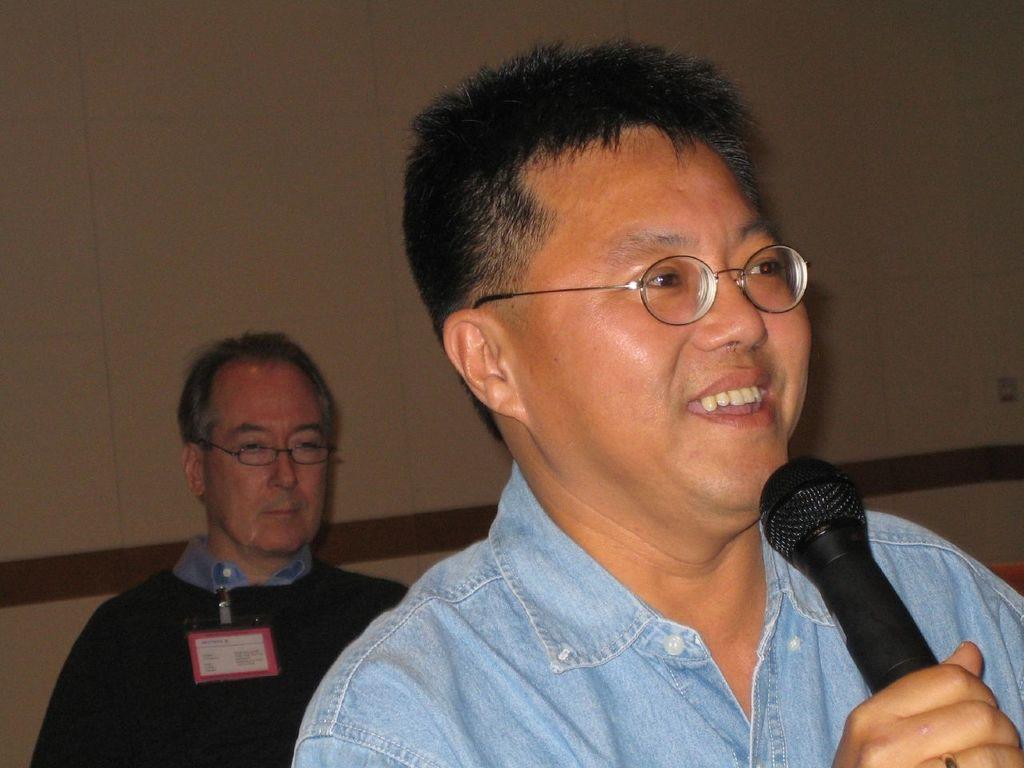How would you summarize this image in a sentence or two? Here we can see a person holding a mike with his hand. He wore spectacles and he is smiling. In the background we can see a person and a wall. 